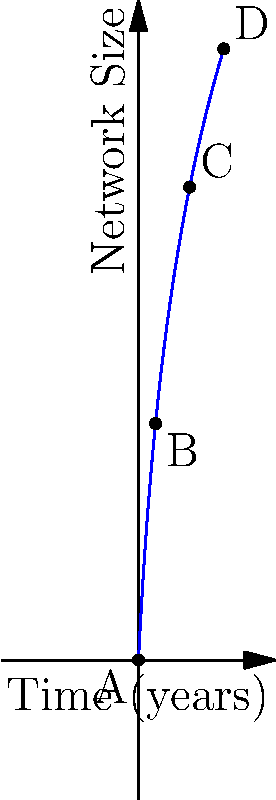The graph represents the growth of your professional network over time. Point A is the starting point (0,0), and the function describing the network growth is $f(x) = 20\log(x+1)$, where $x$ is time in years and $f(x)$ is the network size. If points B, C, and D represent your network size after 1, 3, and 5 years respectively, what is the difference between the network sizes at points D and B? To solve this problem, we need to follow these steps:

1) First, let's calculate the network size at point B (after 1 year):
   $f(1) = 20\log(1+1) = 20\log(2) \approx 13.86$

2) Now, let's calculate the network size at point D (after 5 years):
   $f(5) = 20\log(5+1) = 20\log(6) \approx 35.85$

3) The difference between these two points will give us the growth in network size from year 1 to year 5:
   $f(5) - f(1) = 35.85 - 13.86 = 21.99$

4) Rounding to the nearest whole number (as network size is typically expressed in whole numbers):
   $21.99 \approx 22$

Therefore, the difference in network size between points D and B is approximately 22 connections.
Answer: 22 connections 